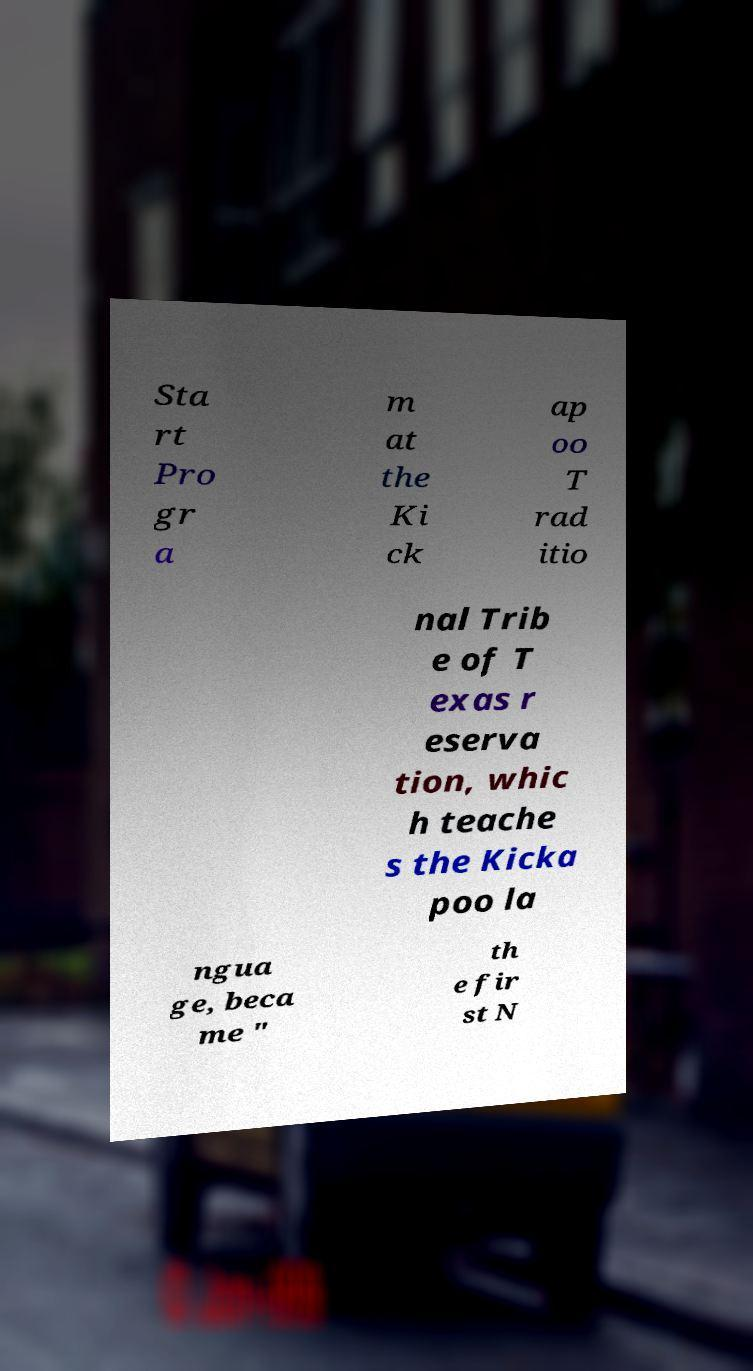There's text embedded in this image that I need extracted. Can you transcribe it verbatim? Sta rt Pro gr a m at the Ki ck ap oo T rad itio nal Trib e of T exas r eserva tion, whic h teache s the Kicka poo la ngua ge, beca me " th e fir st N 